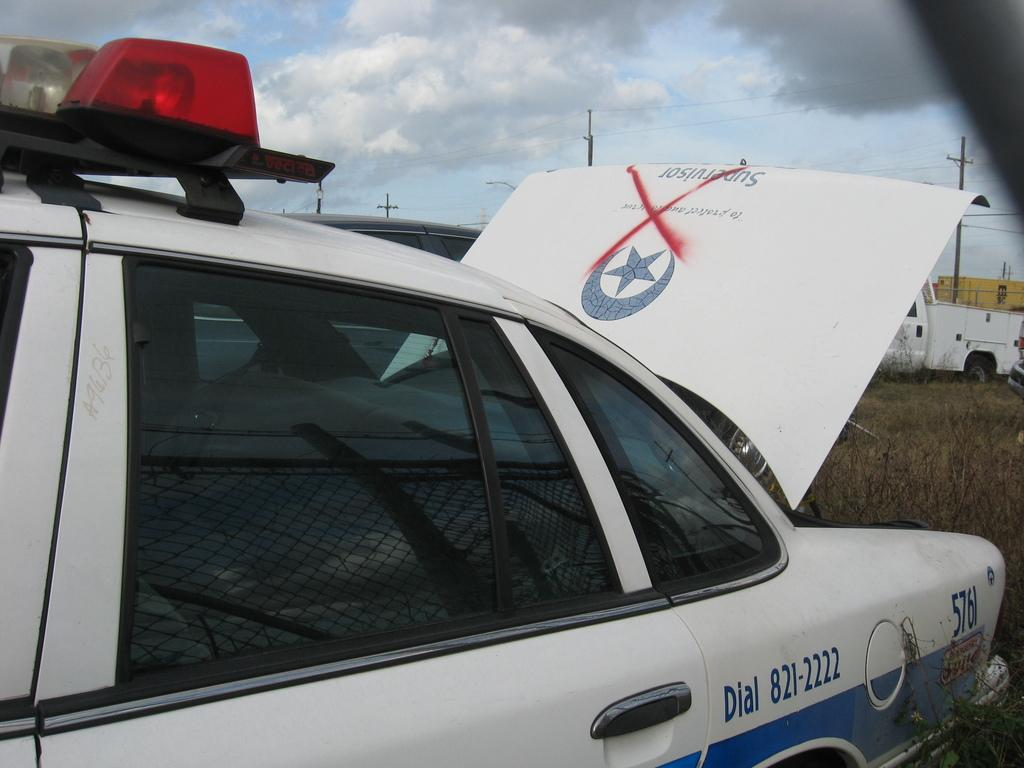What is the main subject of the image? The main subject of the image is a car. What else can be seen in the image besides the car? There are electric poles and plants on the surface visible in the image. What is the condition of the sky in the image? The sky is clear in the image. Can you tell me where the start button for the car is located in the image? There is no information about a start button or any interior details of the car in the image. What type of bedroom can be seen in the image? There is no bedroom present in the image; it features a car, electric poles, plants, and a clear sky. 